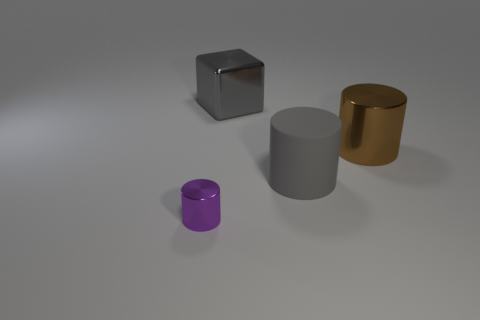Add 4 yellow rubber spheres. How many objects exist? 8 Subtract all cubes. How many objects are left? 3 Subtract 0 blue blocks. How many objects are left? 4 Subtract all big gray shiny things. Subtract all gray metal objects. How many objects are left? 2 Add 4 big matte things. How many big matte things are left? 5 Add 1 tiny metallic spheres. How many tiny metallic spheres exist? 1 